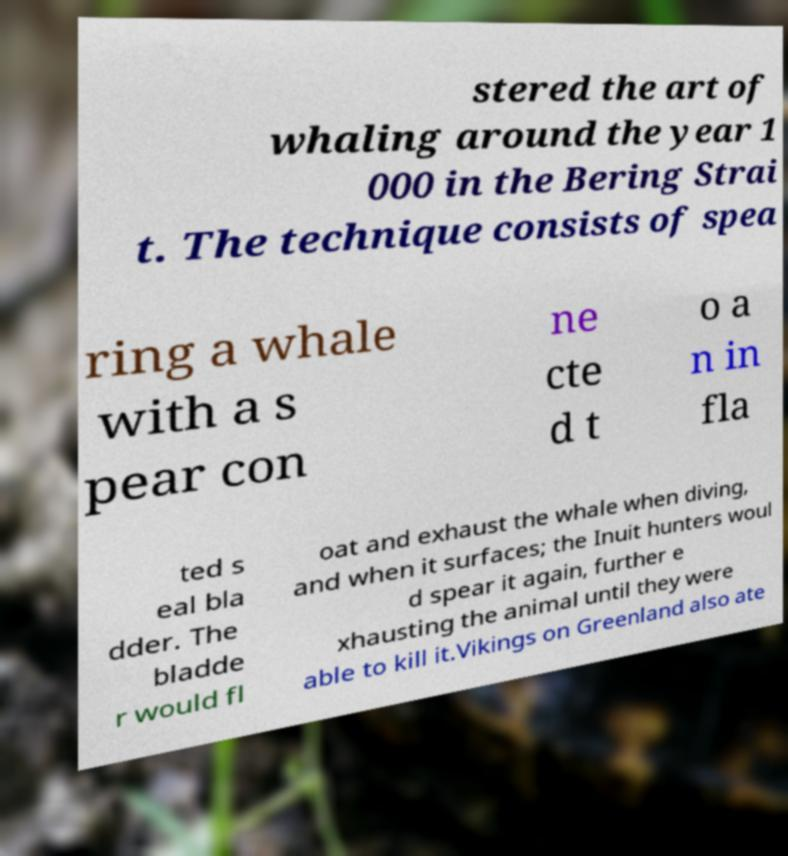Can you read and provide the text displayed in the image?This photo seems to have some interesting text. Can you extract and type it out for me? stered the art of whaling around the year 1 000 in the Bering Strai t. The technique consists of spea ring a whale with a s pear con ne cte d t o a n in fla ted s eal bla dder. The bladde r would fl oat and exhaust the whale when diving, and when it surfaces; the Inuit hunters woul d spear it again, further e xhausting the animal until they were able to kill it.Vikings on Greenland also ate 